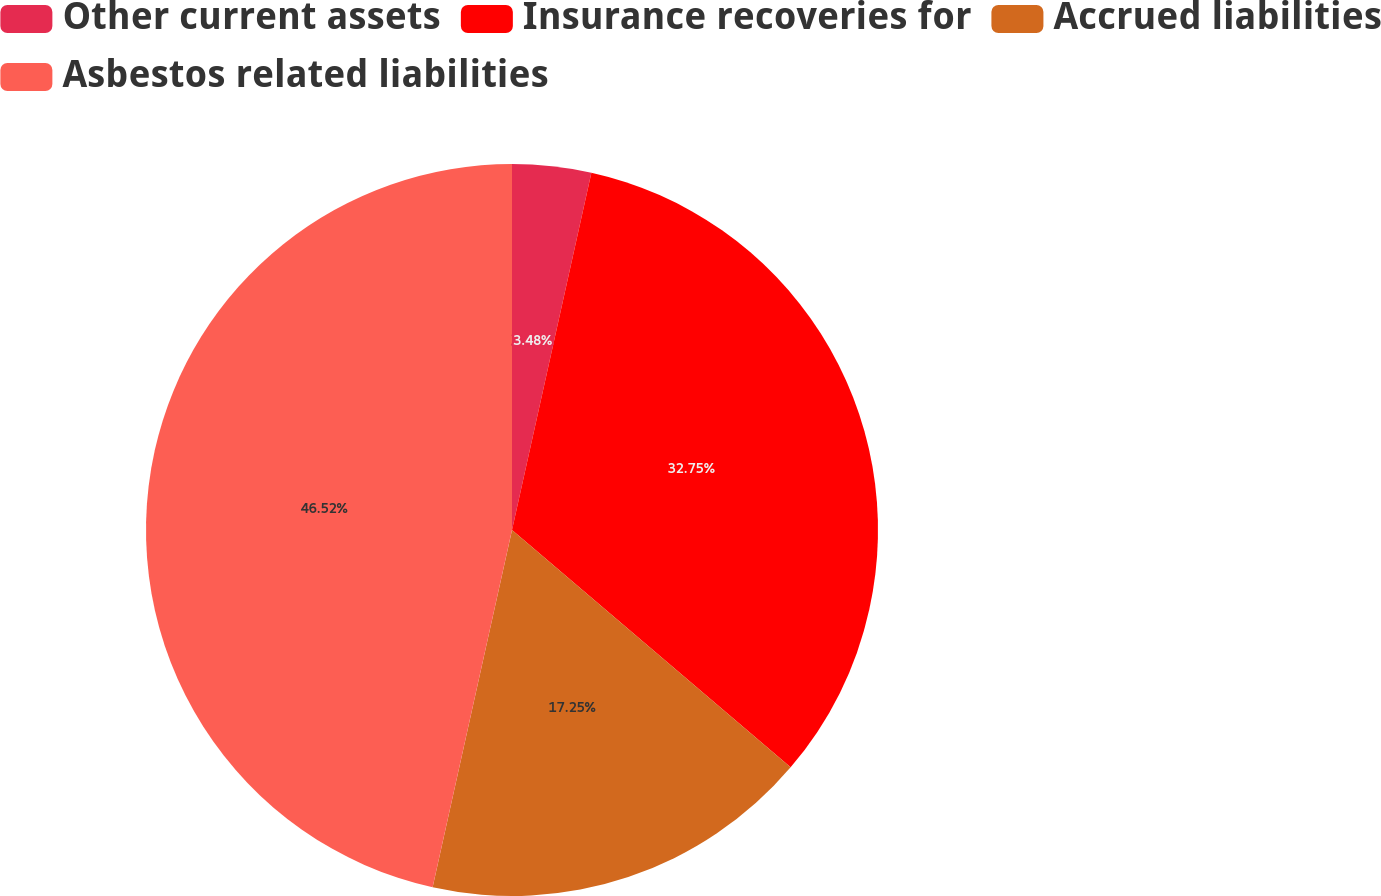<chart> <loc_0><loc_0><loc_500><loc_500><pie_chart><fcel>Other current assets<fcel>Insurance recoveries for<fcel>Accrued liabilities<fcel>Asbestos related liabilities<nl><fcel>3.48%<fcel>32.75%<fcel>17.25%<fcel>46.52%<nl></chart> 